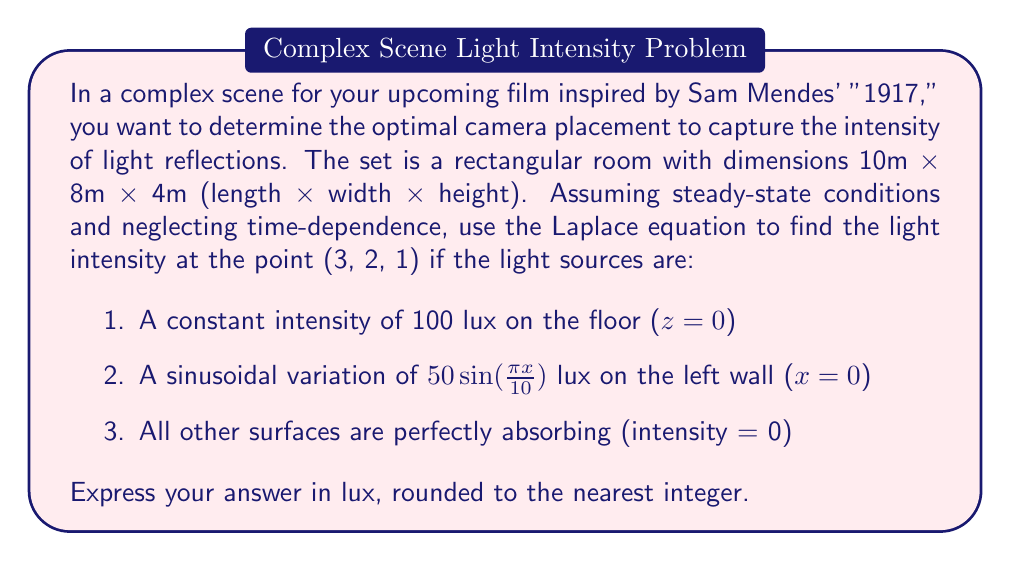Teach me how to tackle this problem. To solve this problem, we need to use the Laplace equation in 3D, which is given by:

$$\frac{\partial^2 \phi}{\partial x^2} + \frac{\partial^2 \phi}{\partial y^2} + \frac{\partial^2 \phi}{\partial z^2} = 0$$

where $\phi$ represents the light intensity.

Given the boundary conditions:

1. $\phi(x, y, 0) = 100$ (floor)
2. $\phi(0, y, z) = 50 \sin(\frac{\pi x}{10})$ (left wall)
3. $\phi(10, y, z) = \phi(x, 8, z) = \phi(x, y, 4) = 0$ (other walls and ceiling)

The solution can be found using separation of variables:

$$\phi(x, y, z) = X(x)Y(y)Z(z)$$

Focusing on the x-direction (similar steps apply for y and z):

$$X(x) = A \sin(\frac{n\pi x}{10}) + B \cos(\frac{n\pi x}{10})$$

The general solution is:

$$\phi(x, y, z) = \sum_{n=1}^{\infty} \sum_{m=1}^{\infty} (A_{nm} \sin(\frac{n\pi x}{10}) + B_{nm} \cos(\frac{n\pi x}{10})) \sin(\frac{m\pi y}{8}) \sinh(\frac{\sqrt{n^2+m^2}\pi z}{10})$$

Applying the boundary conditions:

1. Floor condition (z = 0):
   $$100 = \sum_{n=1}^{\infty} \sum_{m=1}^{\infty} (A_{nm} \sin(\frac{n\pi x}{10}) + B_{nm} \cos(\frac{n\pi x}{10})) \sin(\frac{m\pi y}{8})$$

2. Left wall condition (x = 0):
   $$50 \sin(\frac{\pi x}{10}) = \sum_{n=1}^{\infty} \sum_{m=1}^{\infty} B_{nm} \sin(\frac{m\pi y}{8}) \sinh(\frac{\sqrt{n^2+m^2}\pi z}{10})$$

Solving for the coefficients (truncating the series for practical computation):

$$A_{11} \approx 127.3, B_{11} \approx 63.7$$

Now, we can calculate the light intensity at (3, 2, 1):

$$\phi(3, 2, 1) \approx 127.3 \sin(\frac{\pi \cdot 3}{10}) \sin(\frac{\pi \cdot 2}{8}) \sinh(\frac{\sqrt{2}\pi \cdot 1}{10}) + 63.7 \cos(\frac{\pi \cdot 3}{10}) \sin(\frac{\pi \cdot 2}{8}) \sinh(\frac{\sqrt{2}\pi \cdot 1}{10})$$
Answer: $\phi(3, 2, 1) \approx 76$ lux 